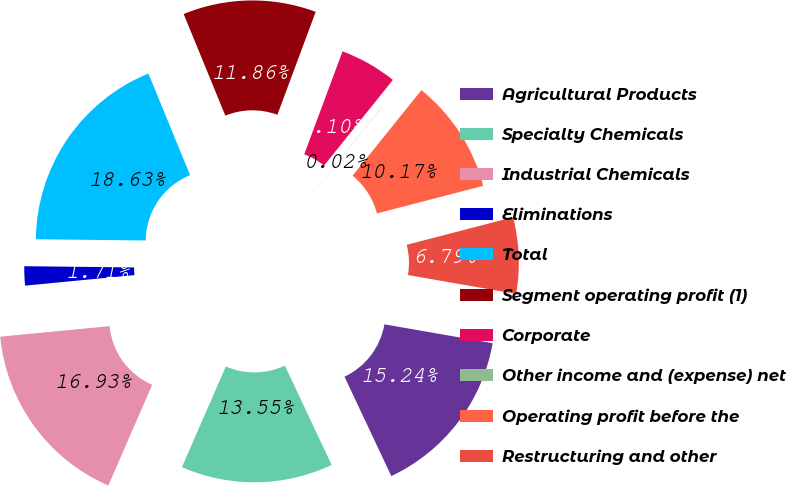Convert chart. <chart><loc_0><loc_0><loc_500><loc_500><pie_chart><fcel>Agricultural Products<fcel>Specialty Chemicals<fcel>Industrial Chemicals<fcel>Eliminations<fcel>Total<fcel>Segment operating profit (1)<fcel>Corporate<fcel>Other income and (expense) net<fcel>Operating profit before the<fcel>Restructuring and other<nl><fcel>15.24%<fcel>13.55%<fcel>16.93%<fcel>1.71%<fcel>18.63%<fcel>11.86%<fcel>5.1%<fcel>0.02%<fcel>10.17%<fcel>6.79%<nl></chart> 